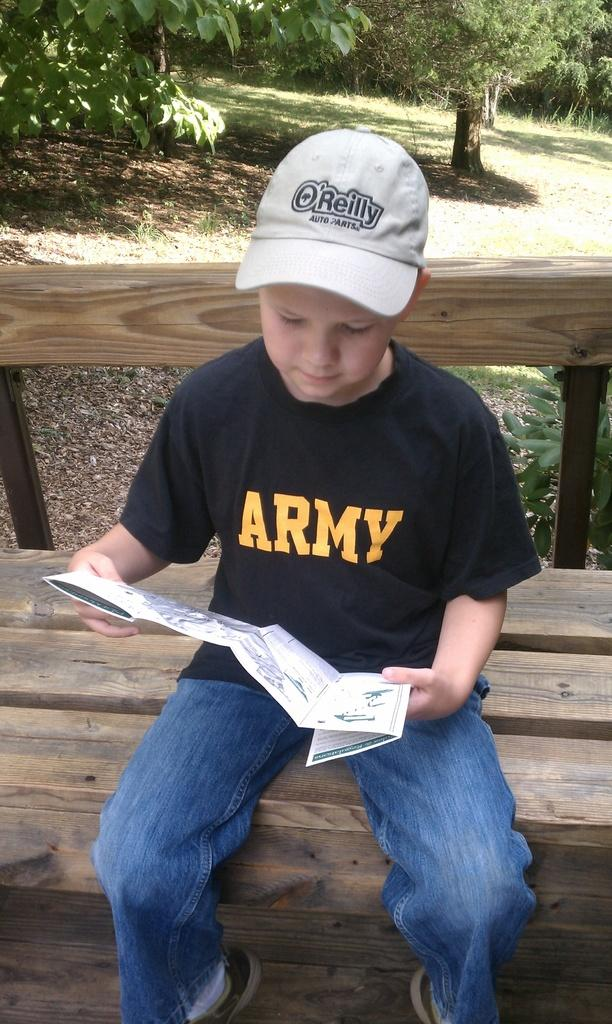What is the main subject of the image? The main subject of the image is a kid. What is the kid doing in the image? The kid is sitting on a bench and reading a pamphlet. What can be seen in the background of the image? There are trees visible in the background of the image. What type of machine is the kid using to read the pamphlet in the image? There is no machine present in the image; the kid is reading the pamphlet without any mechanical assistance. How many fingers does the kid have on their right hand in the image? The number of fingers on the kid's right hand cannot be determined from the image, as it does not provide a clear view of their hand. 